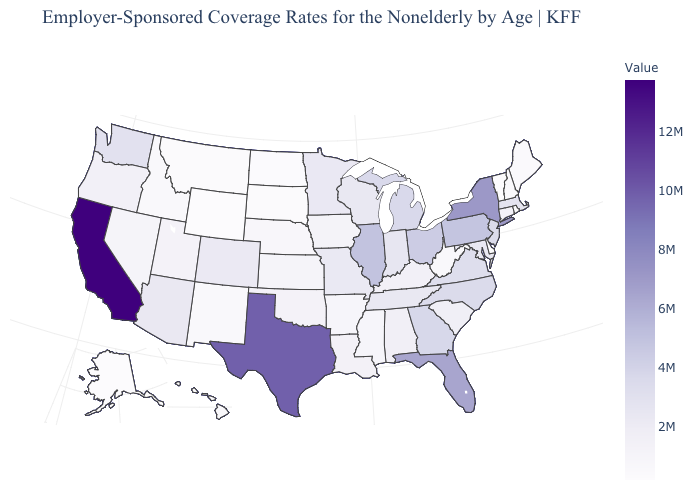Which states have the lowest value in the Northeast?
Concise answer only. Vermont. Does the map have missing data?
Concise answer only. No. Does Massachusetts have the lowest value in the Northeast?
Give a very brief answer. No. 